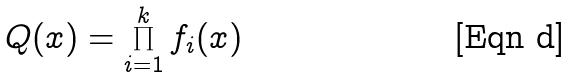<formula> <loc_0><loc_0><loc_500><loc_500>Q ( x ) = \prod _ { i = 1 } ^ { k } f _ { i } ( x )</formula> 